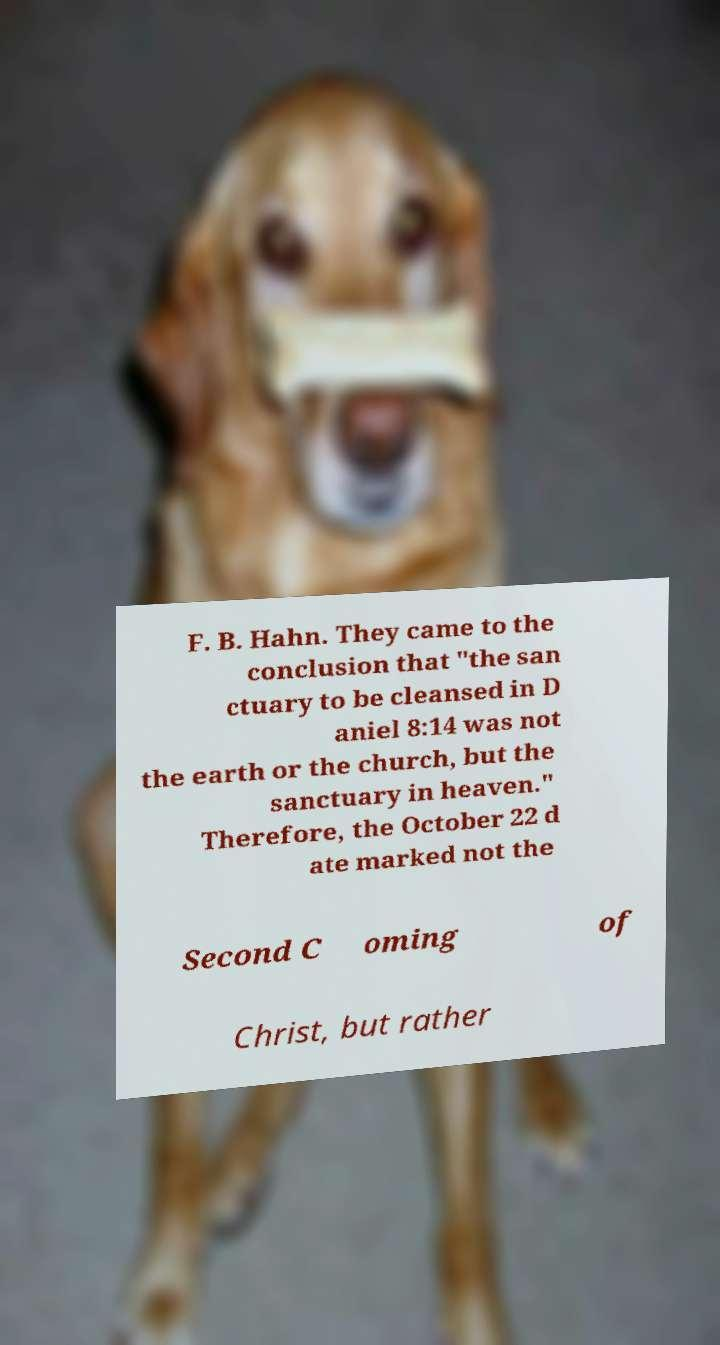What messages or text are displayed in this image? I need them in a readable, typed format. F. B. Hahn. They came to the conclusion that "the san ctuary to be cleansed in D aniel 8:14 was not the earth or the church, but the sanctuary in heaven." Therefore, the October 22 d ate marked not the Second C oming of Christ, but rather 